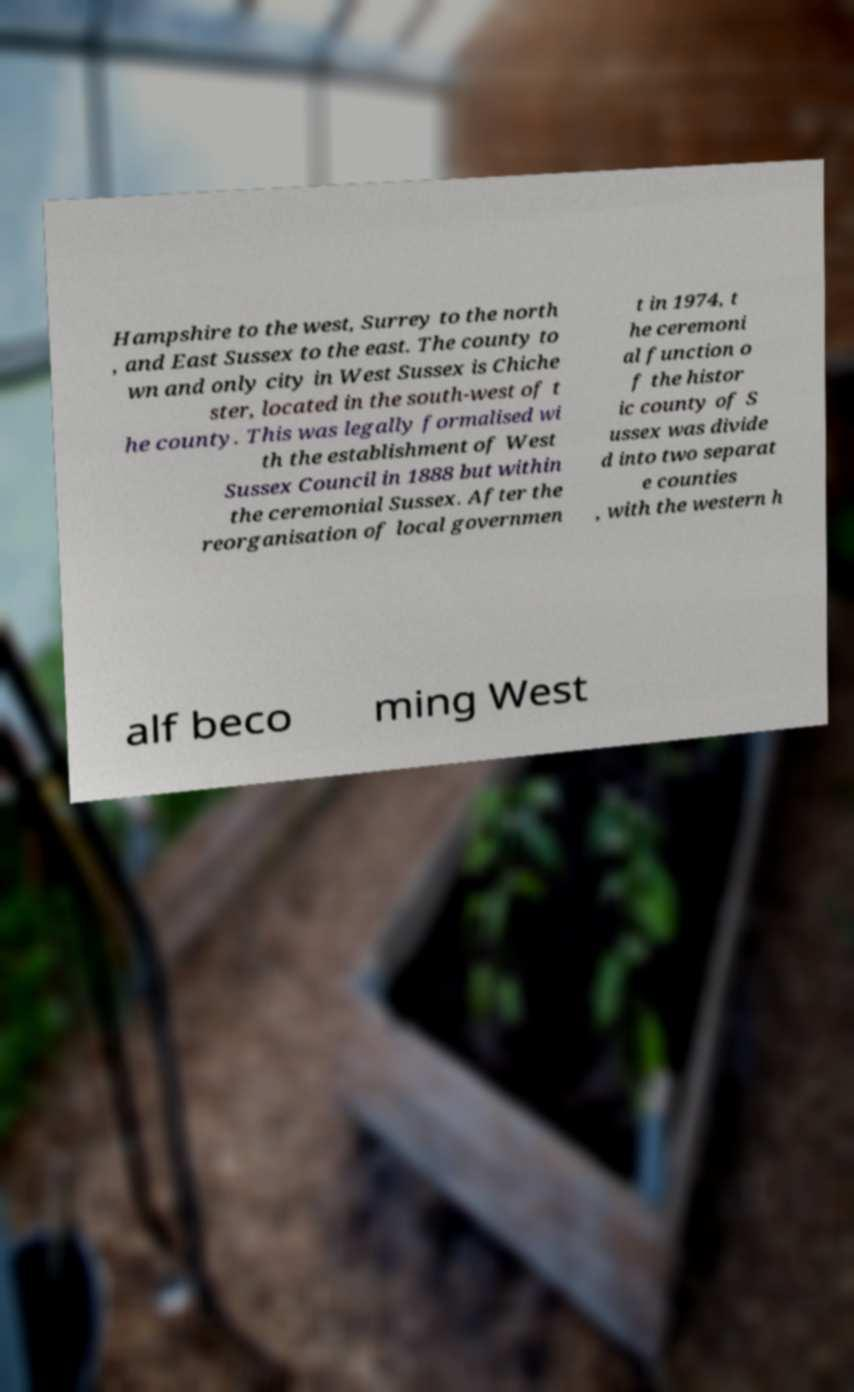Could you assist in decoding the text presented in this image and type it out clearly? Hampshire to the west, Surrey to the north , and East Sussex to the east. The county to wn and only city in West Sussex is Chiche ster, located in the south-west of t he county. This was legally formalised wi th the establishment of West Sussex Council in 1888 but within the ceremonial Sussex. After the reorganisation of local governmen t in 1974, t he ceremoni al function o f the histor ic county of S ussex was divide d into two separat e counties , with the western h alf beco ming West 